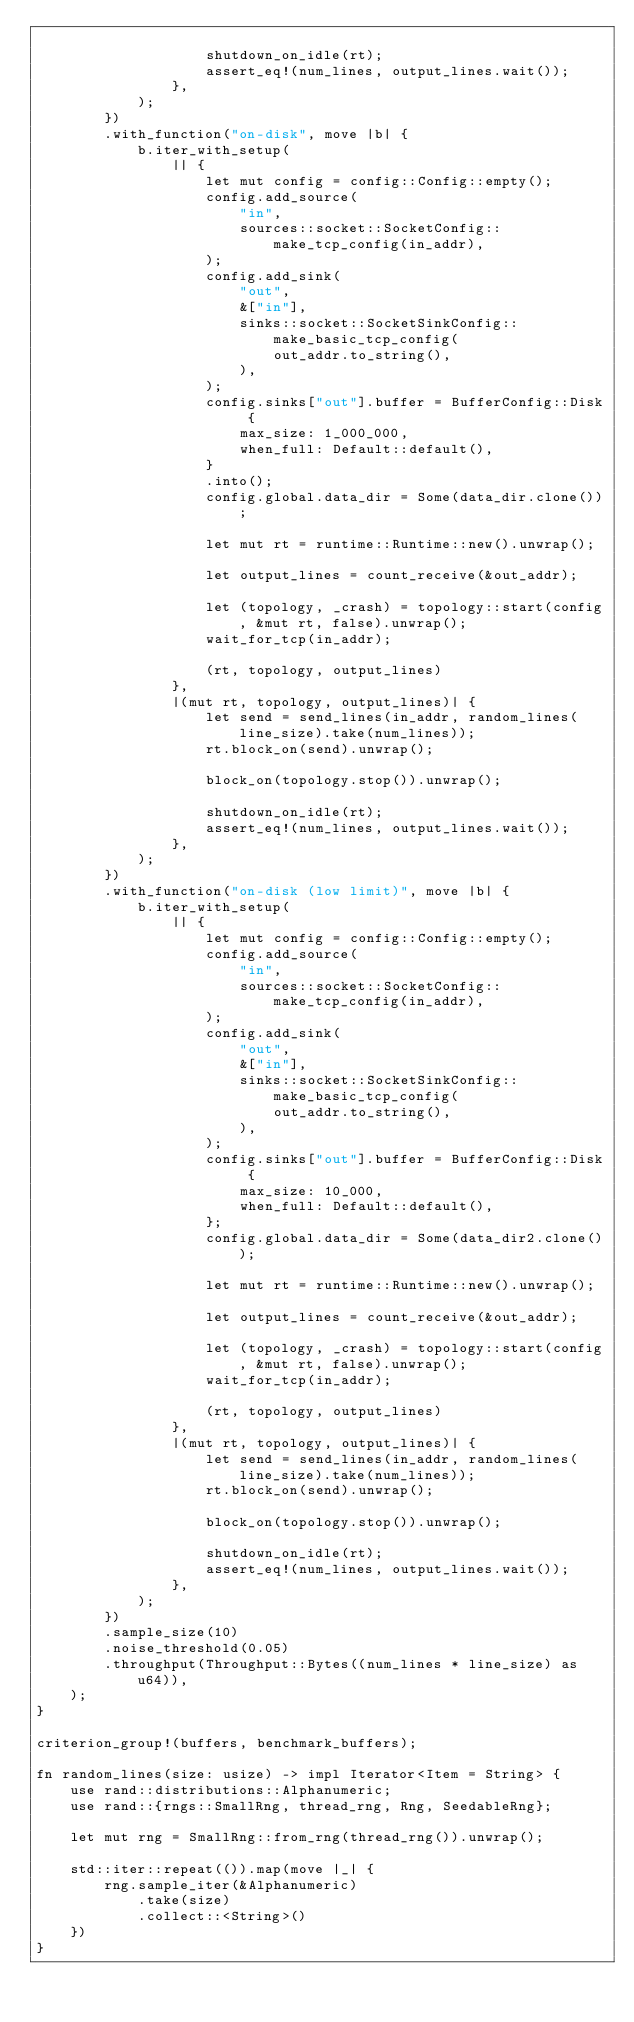<code> <loc_0><loc_0><loc_500><loc_500><_Rust_>
                    shutdown_on_idle(rt);
                    assert_eq!(num_lines, output_lines.wait());
                },
            );
        })
        .with_function("on-disk", move |b| {
            b.iter_with_setup(
                || {
                    let mut config = config::Config::empty();
                    config.add_source(
                        "in",
                        sources::socket::SocketConfig::make_tcp_config(in_addr),
                    );
                    config.add_sink(
                        "out",
                        &["in"],
                        sinks::socket::SocketSinkConfig::make_basic_tcp_config(
                            out_addr.to_string(),
                        ),
                    );
                    config.sinks["out"].buffer = BufferConfig::Disk {
                        max_size: 1_000_000,
                        when_full: Default::default(),
                    }
                    .into();
                    config.global.data_dir = Some(data_dir.clone());

                    let mut rt = runtime::Runtime::new().unwrap();

                    let output_lines = count_receive(&out_addr);

                    let (topology, _crash) = topology::start(config, &mut rt, false).unwrap();
                    wait_for_tcp(in_addr);

                    (rt, topology, output_lines)
                },
                |(mut rt, topology, output_lines)| {
                    let send = send_lines(in_addr, random_lines(line_size).take(num_lines));
                    rt.block_on(send).unwrap();

                    block_on(topology.stop()).unwrap();

                    shutdown_on_idle(rt);
                    assert_eq!(num_lines, output_lines.wait());
                },
            );
        })
        .with_function("on-disk (low limit)", move |b| {
            b.iter_with_setup(
                || {
                    let mut config = config::Config::empty();
                    config.add_source(
                        "in",
                        sources::socket::SocketConfig::make_tcp_config(in_addr),
                    );
                    config.add_sink(
                        "out",
                        &["in"],
                        sinks::socket::SocketSinkConfig::make_basic_tcp_config(
                            out_addr.to_string(),
                        ),
                    );
                    config.sinks["out"].buffer = BufferConfig::Disk {
                        max_size: 10_000,
                        when_full: Default::default(),
                    };
                    config.global.data_dir = Some(data_dir2.clone());

                    let mut rt = runtime::Runtime::new().unwrap();

                    let output_lines = count_receive(&out_addr);

                    let (topology, _crash) = topology::start(config, &mut rt, false).unwrap();
                    wait_for_tcp(in_addr);

                    (rt, topology, output_lines)
                },
                |(mut rt, topology, output_lines)| {
                    let send = send_lines(in_addr, random_lines(line_size).take(num_lines));
                    rt.block_on(send).unwrap();

                    block_on(topology.stop()).unwrap();

                    shutdown_on_idle(rt);
                    assert_eq!(num_lines, output_lines.wait());
                },
            );
        })
        .sample_size(10)
        .noise_threshold(0.05)
        .throughput(Throughput::Bytes((num_lines * line_size) as u64)),
    );
}

criterion_group!(buffers, benchmark_buffers);

fn random_lines(size: usize) -> impl Iterator<Item = String> {
    use rand::distributions::Alphanumeric;
    use rand::{rngs::SmallRng, thread_rng, Rng, SeedableRng};

    let mut rng = SmallRng::from_rng(thread_rng()).unwrap();

    std::iter::repeat(()).map(move |_| {
        rng.sample_iter(&Alphanumeric)
            .take(size)
            .collect::<String>()
    })
}
</code> 